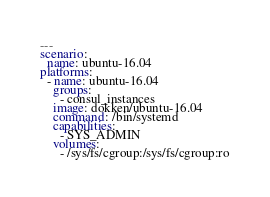<code> <loc_0><loc_0><loc_500><loc_500><_YAML_>---
scenario:
  name: ubuntu-16.04
platforms:
  - name: ubuntu-16.04
    groups:
      - consul_instances
    image: dokken/ubuntu-16.04
    command: /bin/systemd
    capabilities:
      - SYS_ADMIN
    volumes:
      - /sys/fs/cgroup:/sys/fs/cgroup:ro
</code> 